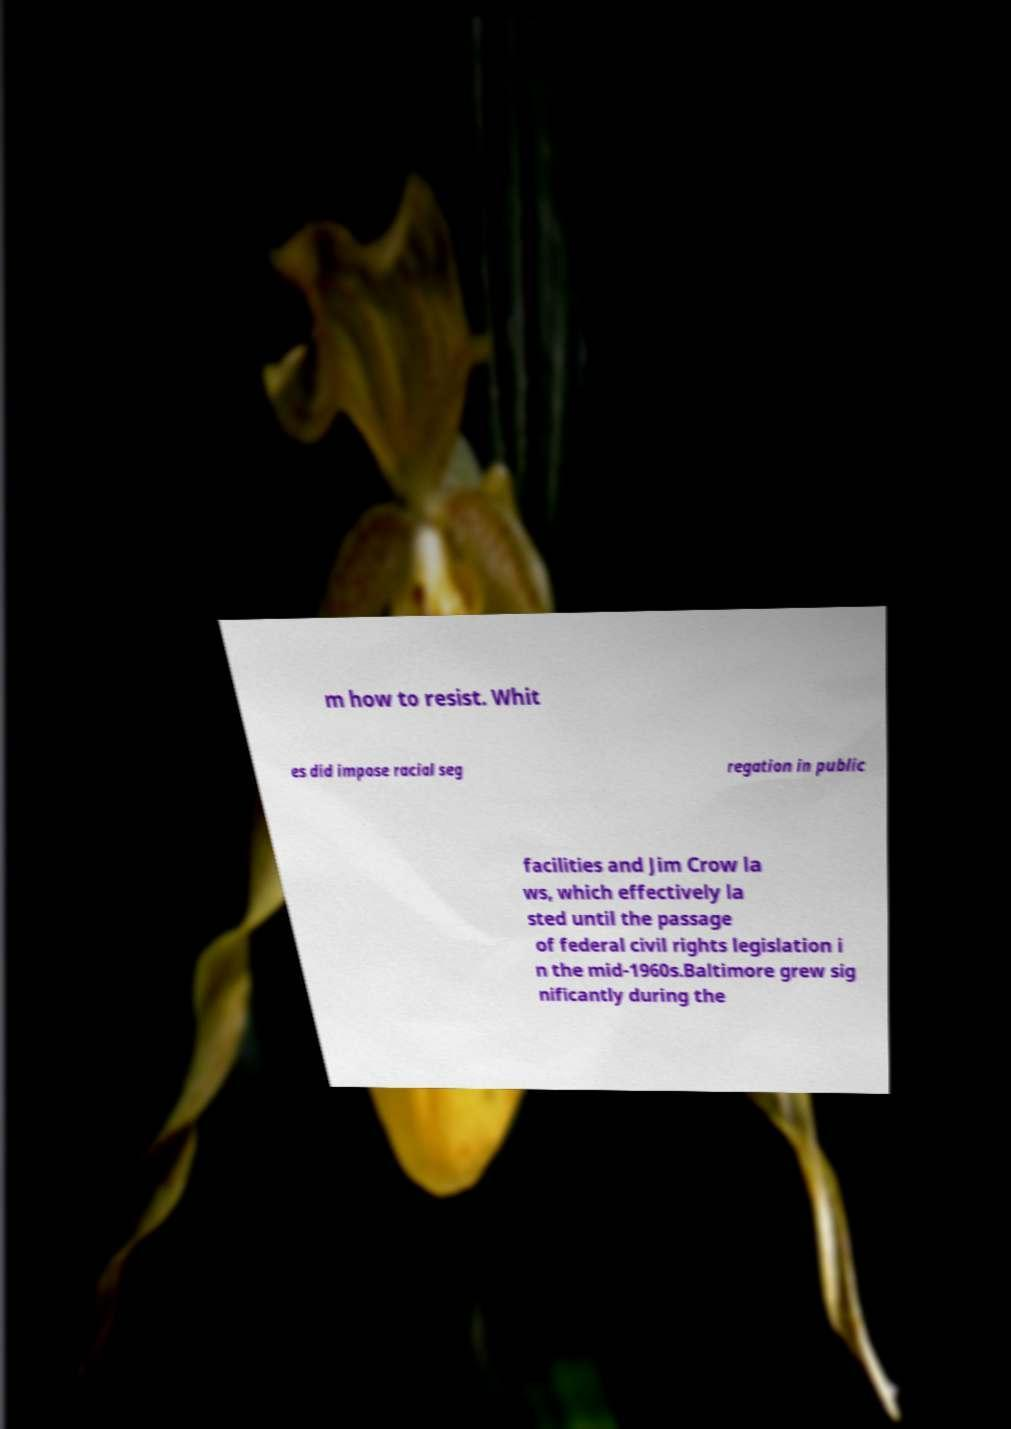There's text embedded in this image that I need extracted. Can you transcribe it verbatim? m how to resist. Whit es did impose racial seg regation in public facilities and Jim Crow la ws, which effectively la sted until the passage of federal civil rights legislation i n the mid-1960s.Baltimore grew sig nificantly during the 